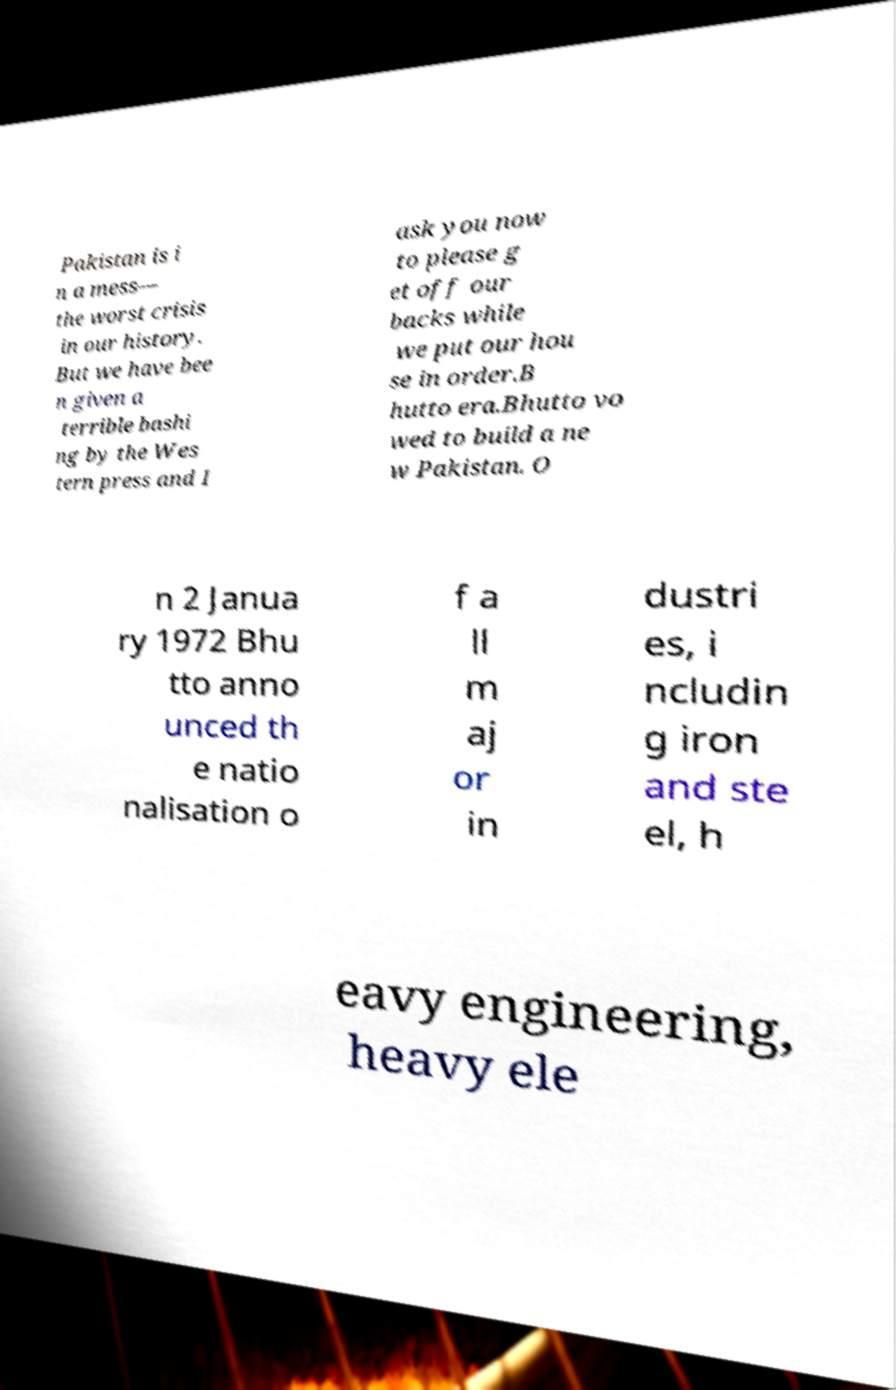Can you read and provide the text displayed in the image?This photo seems to have some interesting text. Can you extract and type it out for me? Pakistan is i n a mess— the worst crisis in our history. But we have bee n given a terrible bashi ng by the Wes tern press and I ask you now to please g et off our backs while we put our hou se in order.B hutto era.Bhutto vo wed to build a ne w Pakistan. O n 2 Janua ry 1972 Bhu tto anno unced th e natio nalisation o f a ll m aj or in dustri es, i ncludin g iron and ste el, h eavy engineering, heavy ele 